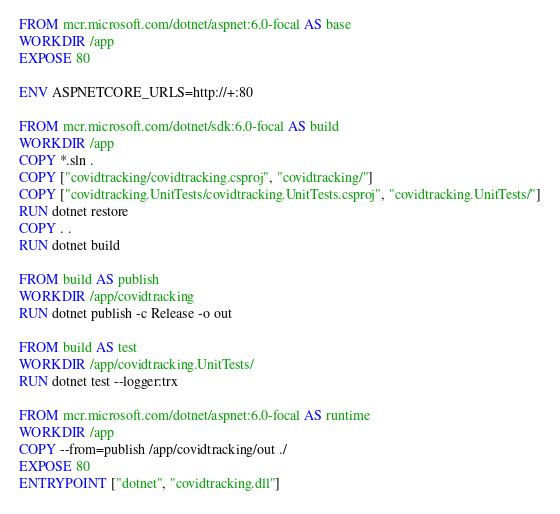<code> <loc_0><loc_0><loc_500><loc_500><_Dockerfile_>FROM mcr.microsoft.com/dotnet/aspnet:6.0-focal AS base
WORKDIR /app
EXPOSE 80

ENV ASPNETCORE_URLS=http://+:80

FROM mcr.microsoft.com/dotnet/sdk:6.0-focal AS build
WORKDIR /app
COPY *.sln .
COPY ["covidtracking/covidtracking.csproj", "covidtracking/"]
COPY ["covidtracking.UnitTests/covidtracking.UnitTests.csproj", "covidtracking.UnitTests/"]
RUN dotnet restore
COPY . .
RUN dotnet build

FROM build AS publish
WORKDIR /app/covidtracking
RUN dotnet publish -c Release -o out

FROM build AS test
WORKDIR /app/covidtracking.UnitTests/
RUN dotnet test --logger:trx

FROM mcr.microsoft.com/dotnet/aspnet:6.0-focal AS runtime
WORKDIR /app
COPY --from=publish /app/covidtracking/out ./
EXPOSE 80
ENTRYPOINT ["dotnet", "covidtracking.dll"]</code> 